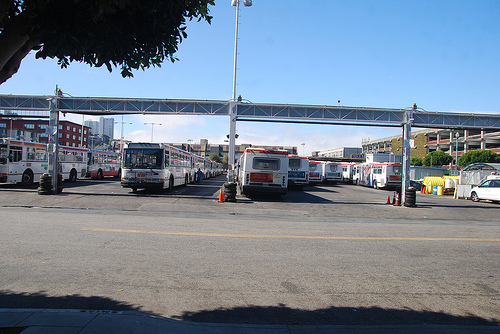What's the primary function of this location? This appears to be a bus depot or transit hub, where buses are parked when not in service or are being prepared for their next routes. 